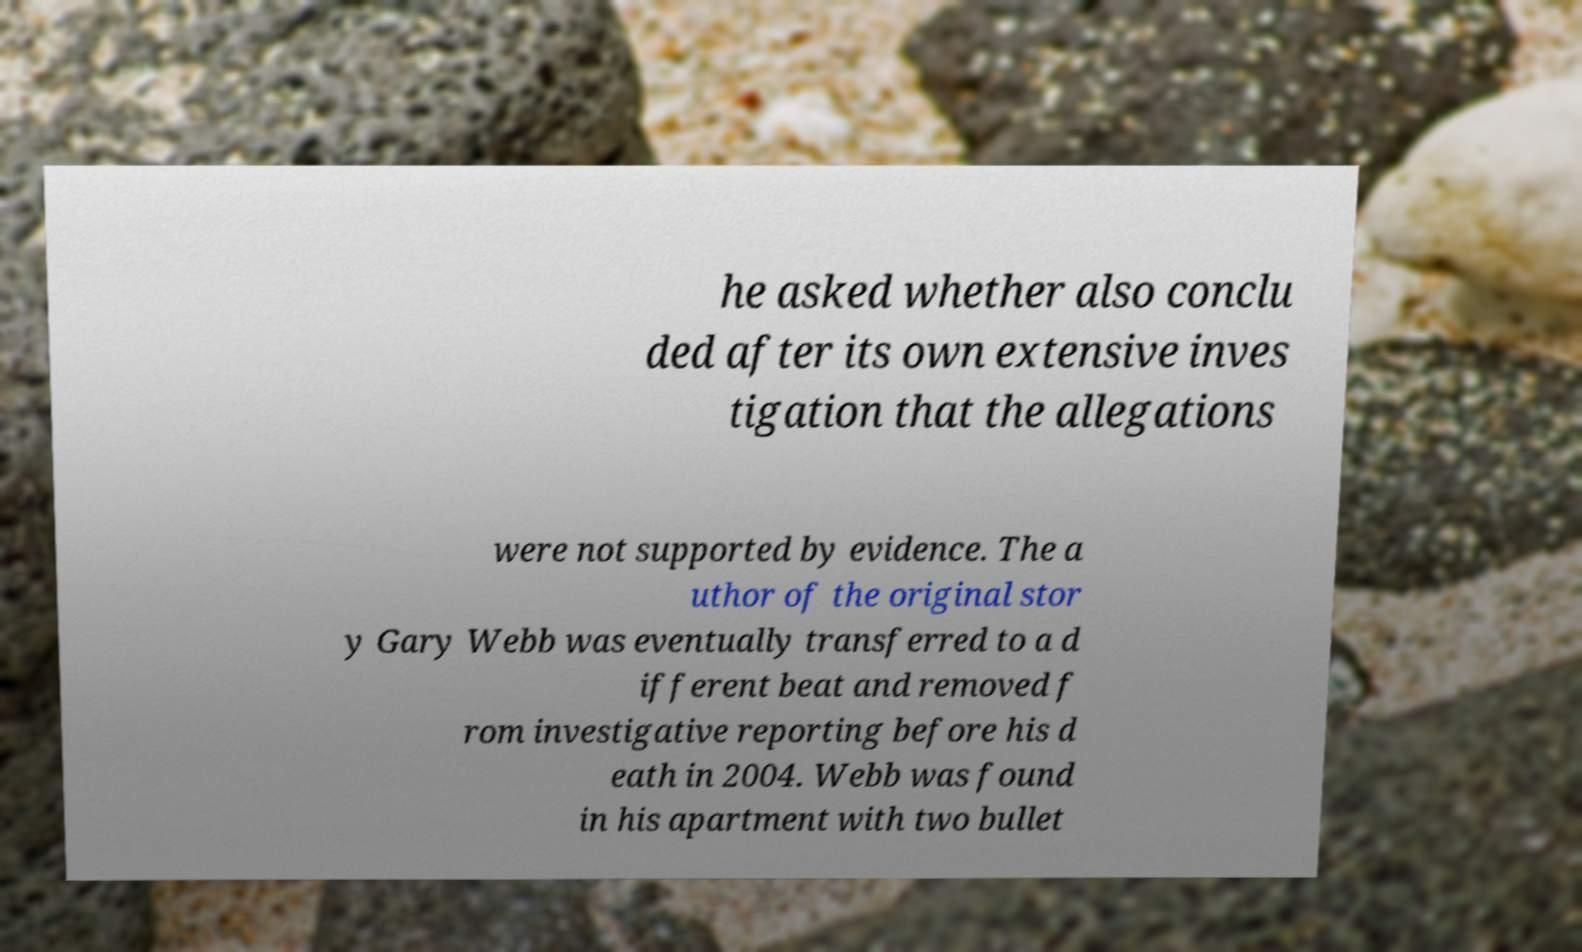Can you read and provide the text displayed in the image?This photo seems to have some interesting text. Can you extract and type it out for me? he asked whether also conclu ded after its own extensive inves tigation that the allegations were not supported by evidence. The a uthor of the original stor y Gary Webb was eventually transferred to a d ifferent beat and removed f rom investigative reporting before his d eath in 2004. Webb was found in his apartment with two bullet 